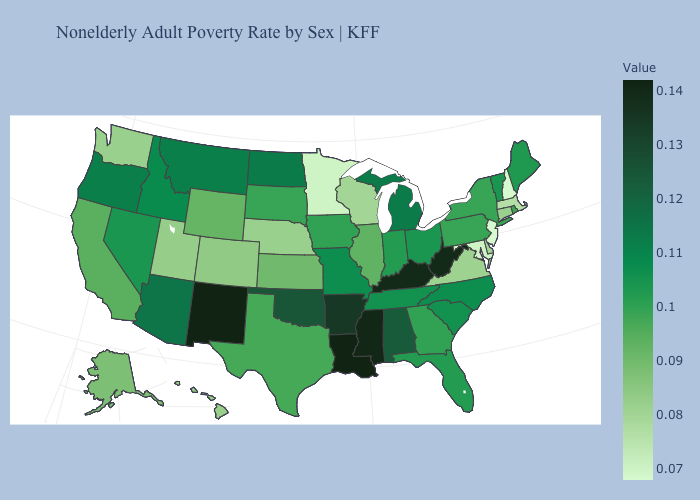Among the states that border Oregon , which have the lowest value?
Give a very brief answer. Washington. Does Virginia have a higher value than Kentucky?
Quick response, please. No. Is the legend a continuous bar?
Concise answer only. Yes. Which states have the lowest value in the USA?
Short answer required. New Hampshire, New Jersey. Is the legend a continuous bar?
Keep it brief. Yes. Among the states that border Wisconsin , which have the highest value?
Quick response, please. Michigan. Among the states that border Oklahoma , does New Mexico have the highest value?
Be succinct. Yes. 